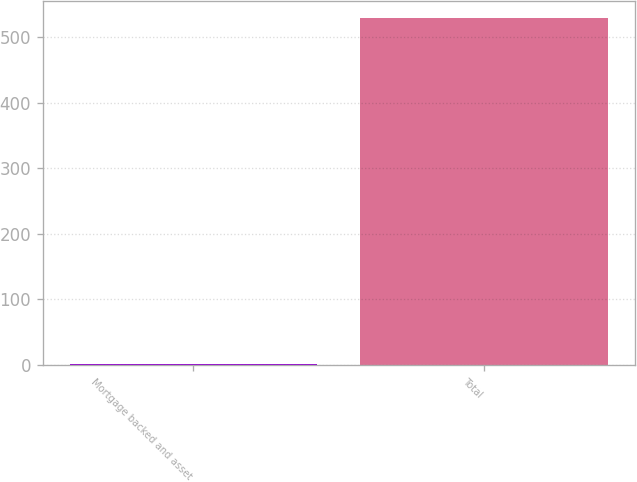Convert chart to OTSL. <chart><loc_0><loc_0><loc_500><loc_500><bar_chart><fcel>Mortgage backed and asset<fcel>Total<nl><fcel>2<fcel>529<nl></chart> 